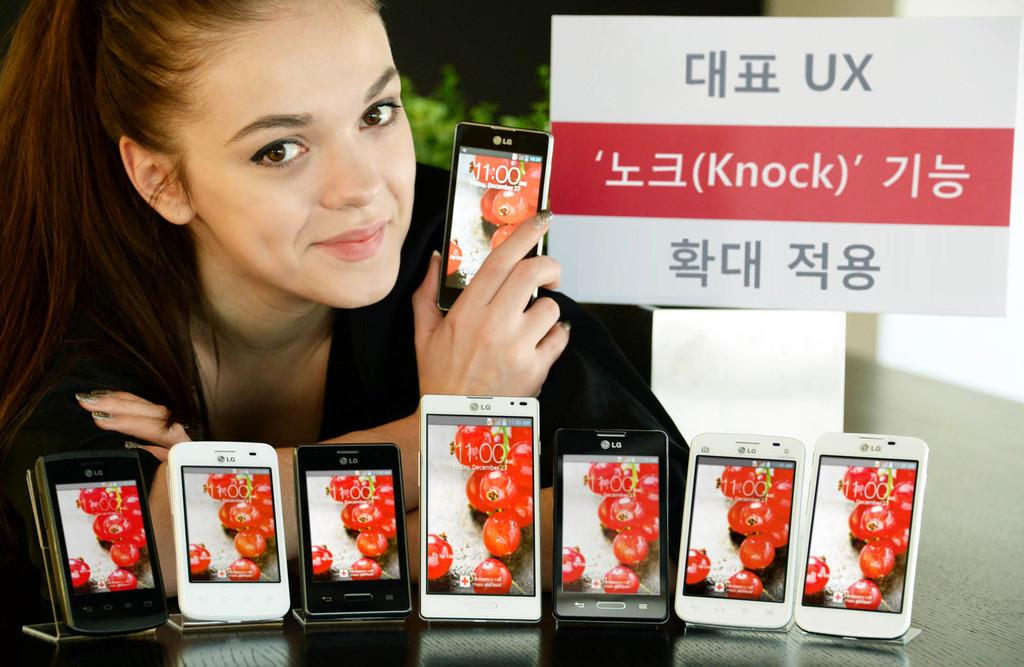Who is the main subject in the image? There is a woman in the image. What is the woman holding in her hand? The woman is holding a mobile phone in her hand. What is the woman doing in the image? The woman is giving a pose. What else can be seen on the table in front of the woman? There are mobile phones on a table in front of the woman. What is visible on the right side of the image? There is a hoarding on the right side of the image. What type of kitten can be seen bursting a liquid-filled balloon in the image? There is no kitten or liquid-filled balloon present in the image. 